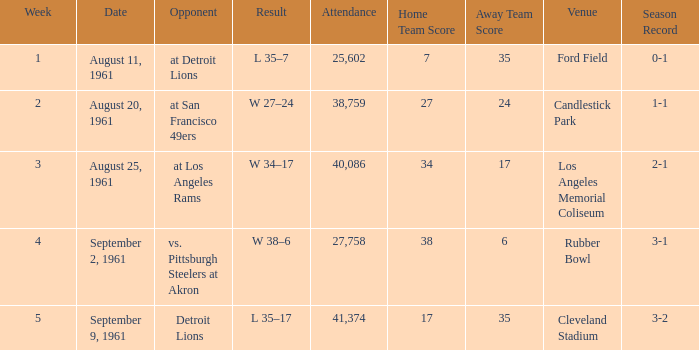What was the score of the Browns week 4 game? W 38–6. 